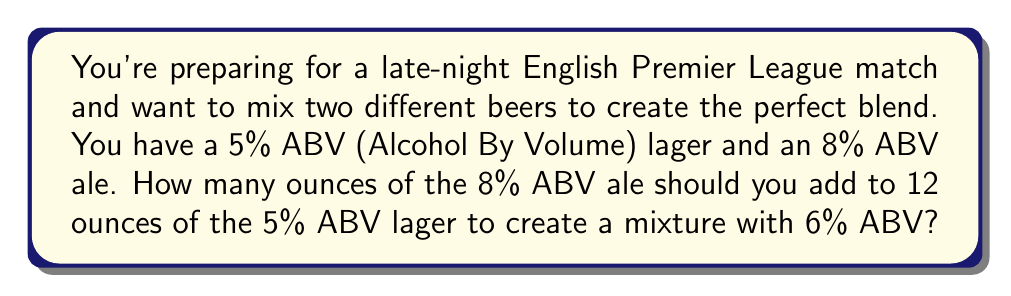Provide a solution to this math problem. Let's approach this step-by-step using a linear equation:

1) Let $x$ be the number of ounces of 8% ABV ale we need to add.

2) The total volume of the mixture will be $(12 + x)$ ounces.

3) The total amount of pure alcohol in the mixture should be 6% of the total volume:
   $0.06(12 + x)$

4) We can set up an equation based on the fact that the total amount of alcohol in the mixture should equal the sum of alcohol from each beer:

   $0.05(12) + 0.08x = 0.06(12 + x)$

5) Let's solve this equation:
   $0.6 + 0.08x = 0.72 + 0.06x$
   $0.6 + 0.08x = 0.72 + 0.06x$
   $0.08x - 0.06x = 0.72 - 0.6$
   $0.02x = 0.12$
   $x = 0.12 / 0.02 = 6$

Therefore, you should add 6 ounces of the 8% ABV ale to 12 ounces of the 5% ABV lager.
Answer: 6 ounces 